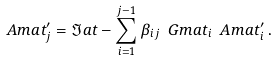<formula> <loc_0><loc_0><loc_500><loc_500>\ A m a t ^ { \prime } _ { j } = \Im a t - \sum _ { i = 1 } ^ { j - 1 } \beta _ { i j } \ G m a t _ { i } \ A m a t ^ { \prime } _ { i } \, .</formula> 